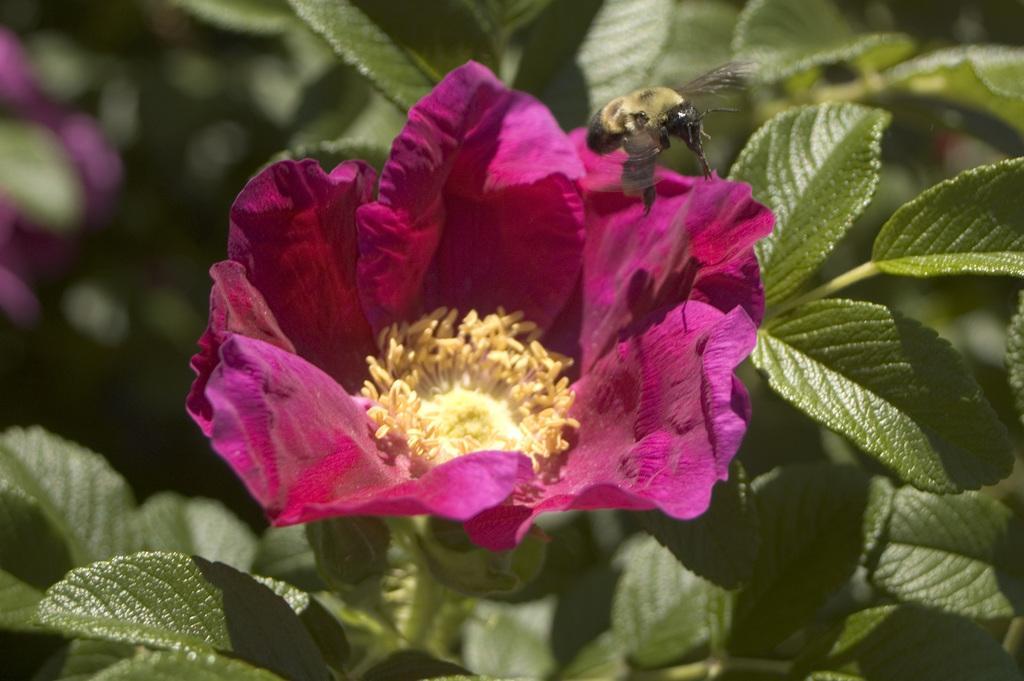Can you describe this image briefly? In this image I can see an insect which is cream and black in color is flying in the air and a flower which is cream, pink and yellow in color to a tree which is green in color. I can see the blurry background which is green, pink and cream in color. 